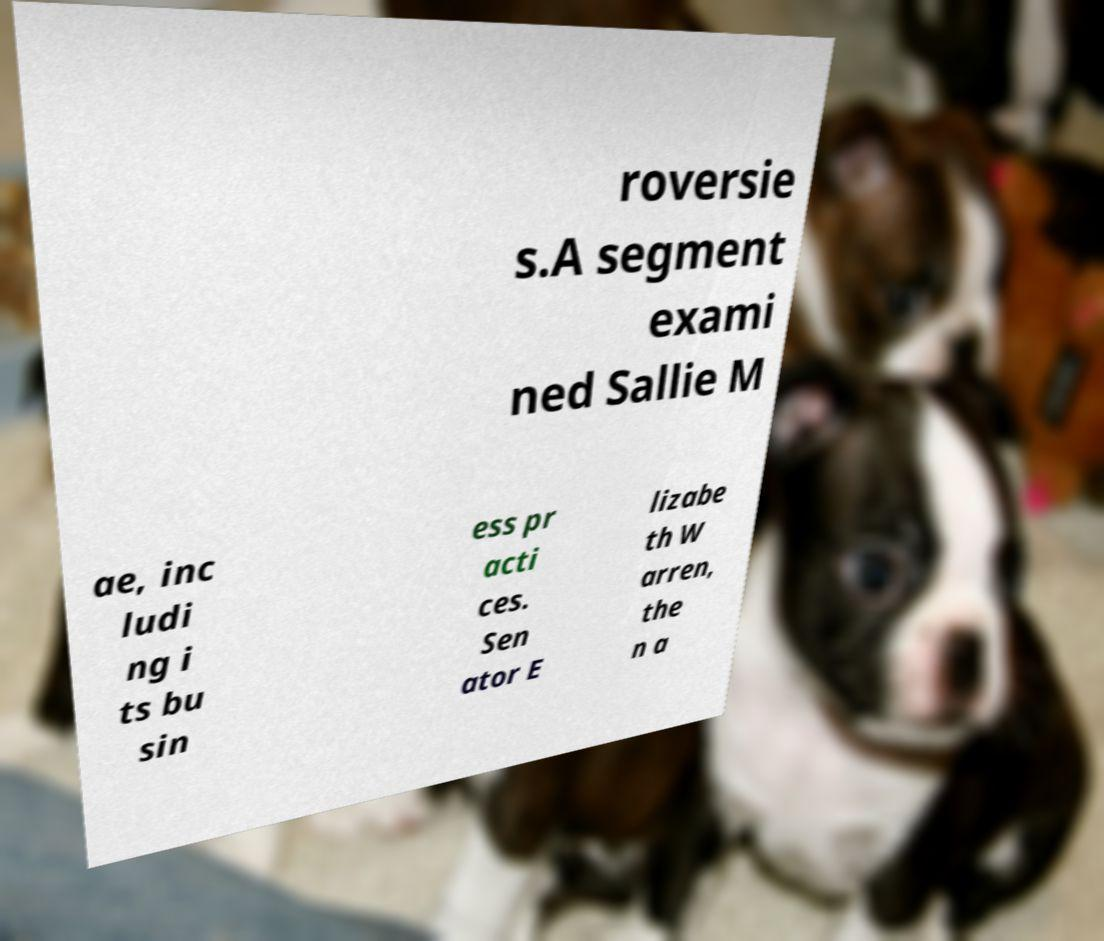Can you accurately transcribe the text from the provided image for me? roversie s.A segment exami ned Sallie M ae, inc ludi ng i ts bu sin ess pr acti ces. Sen ator E lizabe th W arren, the n a 